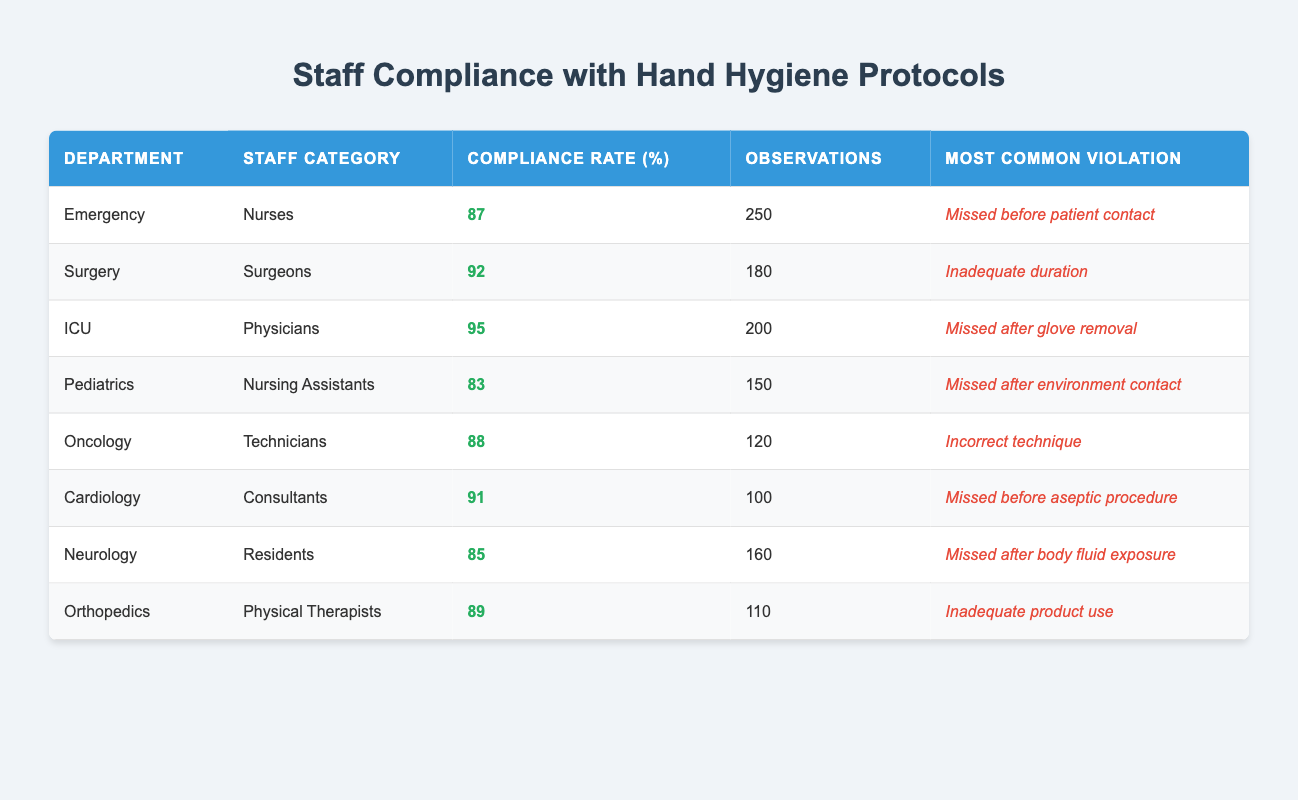What is the compliance rate for the ICU department? The ICU department has a compliance rate listed in the table, which is specifically noted under the "Compliance Rate (%)" column for that department. The value is 95%.
Answer: 95% Which staff category has the highest compliance rate? To find the staff category with the highest compliance rate, I compare the individual compliance rates listed in the table. The highest rate is 95%, which belongs to the Physicians in the ICU department.
Answer: Physicians How many observations were recorded for the Nursing Assistants in Pediatrics? The number of observations for Nursing Assistants in Pediatrics is provided directly in the table under the "Observations" column. The recorded number is 150.
Answer: 150 What is the difference between the compliance rates of the highest and lowest compliance staff categories? The highest compliance rate is 95% (Physicians, ICU) and the lowest is 83% (Nursing Assistants, Pediatrics). The difference is calculated as 95% - 83% = 12%.
Answer: 12% Is it true that the Most Common Violation for Surgeons is "Missed after glove removal"? To confirm this, I check the table for the Surgeons entry under the "Most Common Violation" column. The entry states "Inadequate duration", not "Missed after glove removal", so the statement is false.
Answer: No What is the average compliance rate of staff in the Emergency and Surgery departments? The compliance rates for the Emergency (87%) and Surgery (92%) departments are summed up, which gives 87 + 92 = 179. To find the average, I divide this sum by 2, resulting in an average of 179 / 2 = 89.5%.
Answer: 89.5% Which department's staff most commonly violates the hand hygiene protocol by missing contact after the environment? The table shows that the most common violation listed for Nursing Assistants in the Pediatrics department is "Missed after environment contact." Thus, that's the department that corresponds to this violation.
Answer: Pediatrics What are the most common violations for the staff categories with compliance rates above 90%? The staff categories with compliance rates above 90% are ICU Physicians (Missed after glove removal) and Surgeons (Inadequate duration), as well as Cardiology Consultants (Missed before aseptic procedure). Thus, the common violations for these categories are noted under the "Most Common Violation" column, which are as stated.
Answer: Missed after glove removal, Inadequate duration, Missed before aseptic procedure What is the total number of observations made for all staff categories combined? The total number of observations is calculated by summing the values from the "Observations" column: 250 + 180 + 200 + 150 + 120 + 100 + 160 + 110 = 1270.
Answer: 1270 